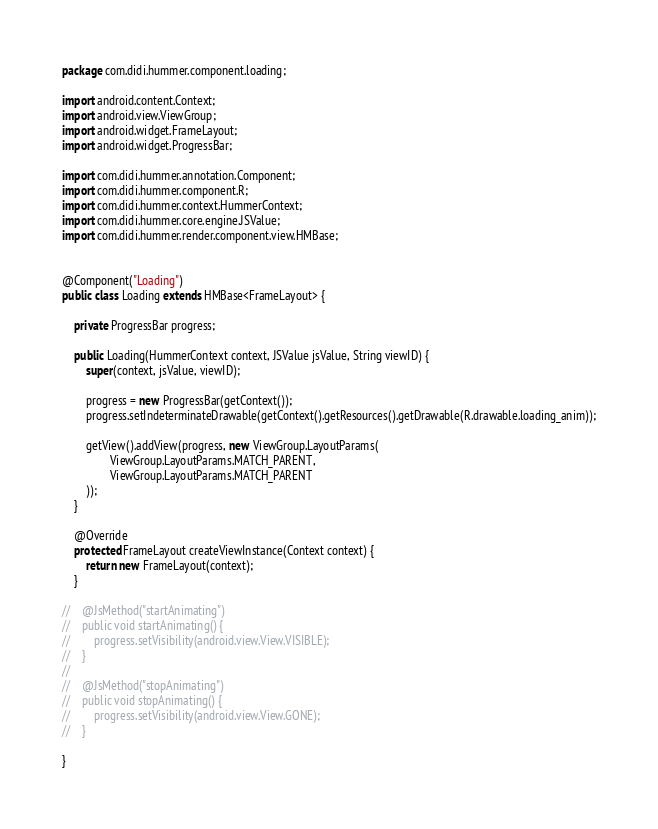<code> <loc_0><loc_0><loc_500><loc_500><_Java_>package com.didi.hummer.component.loading;

import android.content.Context;
import android.view.ViewGroup;
import android.widget.FrameLayout;
import android.widget.ProgressBar;

import com.didi.hummer.annotation.Component;
import com.didi.hummer.component.R;
import com.didi.hummer.context.HummerContext;
import com.didi.hummer.core.engine.JSValue;
import com.didi.hummer.render.component.view.HMBase;


@Component("Loading")
public class Loading extends HMBase<FrameLayout> {

    private ProgressBar progress;

    public Loading(HummerContext context, JSValue jsValue, String viewID) {
        super(context, jsValue, viewID);

        progress = new ProgressBar(getContext());
        progress.setIndeterminateDrawable(getContext().getResources().getDrawable(R.drawable.loading_anim));

        getView().addView(progress, new ViewGroup.LayoutParams(
                ViewGroup.LayoutParams.MATCH_PARENT,
                ViewGroup.LayoutParams.MATCH_PARENT
        ));
    }

    @Override
    protected FrameLayout createViewInstance(Context context) {
        return new FrameLayout(context);
    }

//    @JsMethod("startAnimating")
//    public void startAnimating() {
//        progress.setVisibility(android.view.View.VISIBLE);
//    }
//
//    @JsMethod("stopAnimating")
//    public void stopAnimating() {
//        progress.setVisibility(android.view.View.GONE);
//    }

}
</code> 